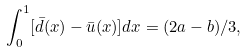Convert formula to latex. <formula><loc_0><loc_0><loc_500><loc_500>\int _ { 0 } ^ { 1 } [ \bar { d } ( x ) - \bar { u } ( x ) ] d x = ( 2 a - b ) / 3 ,</formula> 